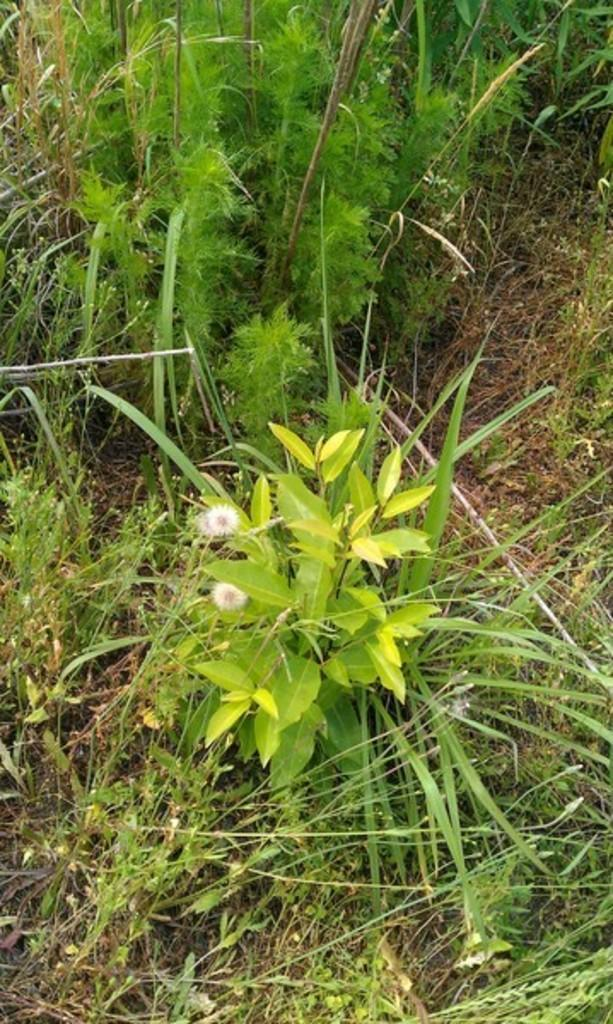What type of vegetation can be seen in the image? There are plants and flowers visible in the image. What is at the bottom of the image? There is grass at the bottom of the image. What type of paste is being used to balance the flowers in the image? There is no paste or balancing act involving the flowers in the image; they are simply visible among the plants. 